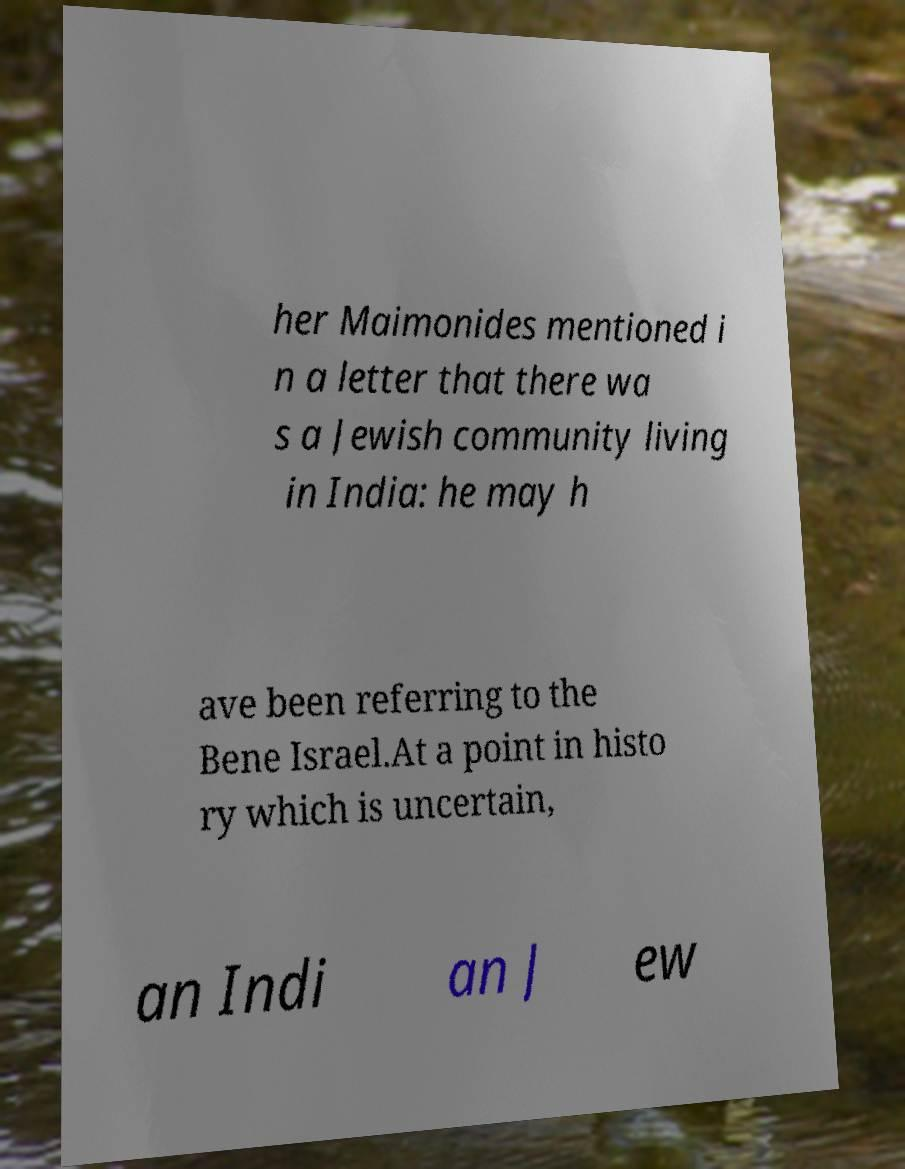What messages or text are displayed in this image? I need them in a readable, typed format. her Maimonides mentioned i n a letter that there wa s a Jewish community living in India: he may h ave been referring to the Bene Israel.At a point in histo ry which is uncertain, an Indi an J ew 